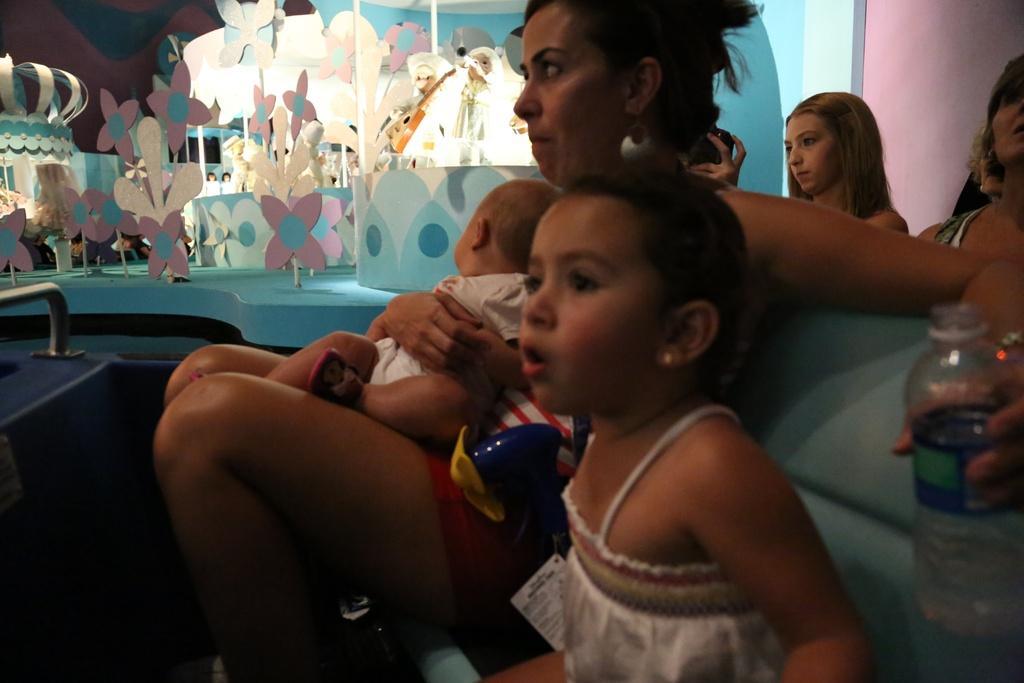Can you describe this image briefly? In the image we can see there are people sitting on the chair sofa and the woman is holding water bottle in her hand. Behind there are toys and flower statue kept on the stage. 